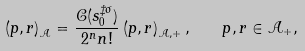<formula> <loc_0><loc_0><loc_500><loc_500>\left ( p , r \right ) _ { \mathcal { A } } = \frac { \mathcal { C } ( s _ { 0 } ^ { \ddagger \sigma } ) } { 2 ^ { n } n ! } \left ( p , r \right ) _ { \mathcal { A } , + } , \quad p , r \in \mathcal { A } _ { + } ,</formula> 